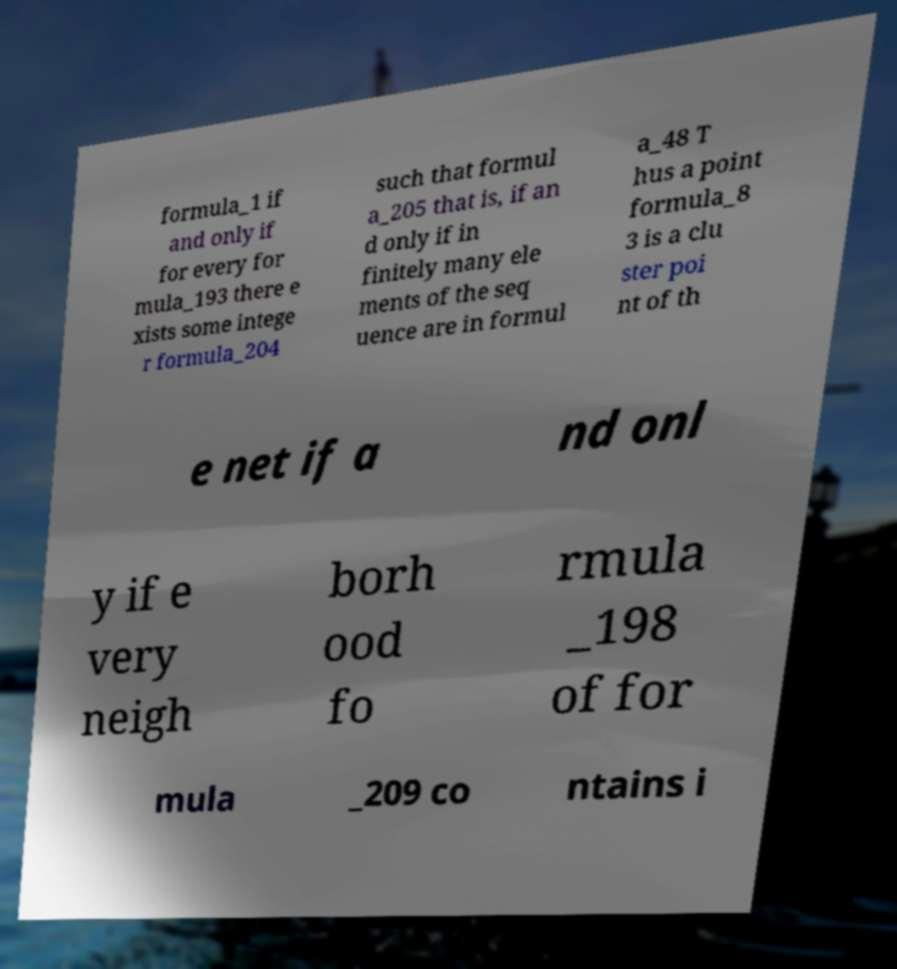Could you extract and type out the text from this image? formula_1 if and only if for every for mula_193 there e xists some intege r formula_204 such that formul a_205 that is, if an d only if in finitely many ele ments of the seq uence are in formul a_48 T hus a point formula_8 3 is a clu ster poi nt of th e net if a nd onl y if e very neigh borh ood fo rmula _198 of for mula _209 co ntains i 